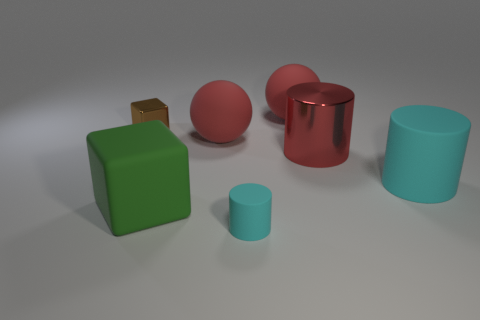Subtract all tiny cylinders. How many cylinders are left? 2 Add 3 shiny objects. How many objects exist? 10 Subtract all purple balls. How many cyan cylinders are left? 2 Subtract 1 cylinders. How many cylinders are left? 2 Subtract all cylinders. How many objects are left? 4 Subtract all red cylinders. How many cylinders are left? 2 Subtract all tiny cyan rubber objects. Subtract all cyan rubber objects. How many objects are left? 4 Add 3 big red matte objects. How many big red matte objects are left? 5 Add 6 cyan metallic balls. How many cyan metallic balls exist? 6 Subtract 0 brown cylinders. How many objects are left? 7 